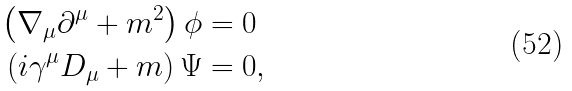<formula> <loc_0><loc_0><loc_500><loc_500>\left ( \nabla _ { \mu } \partial ^ { \mu } + m ^ { 2 } \right ) \phi & = 0 \\ \left ( i \gamma ^ { \mu } D _ { \mu } + m \right ) \Psi & = 0 ,</formula> 